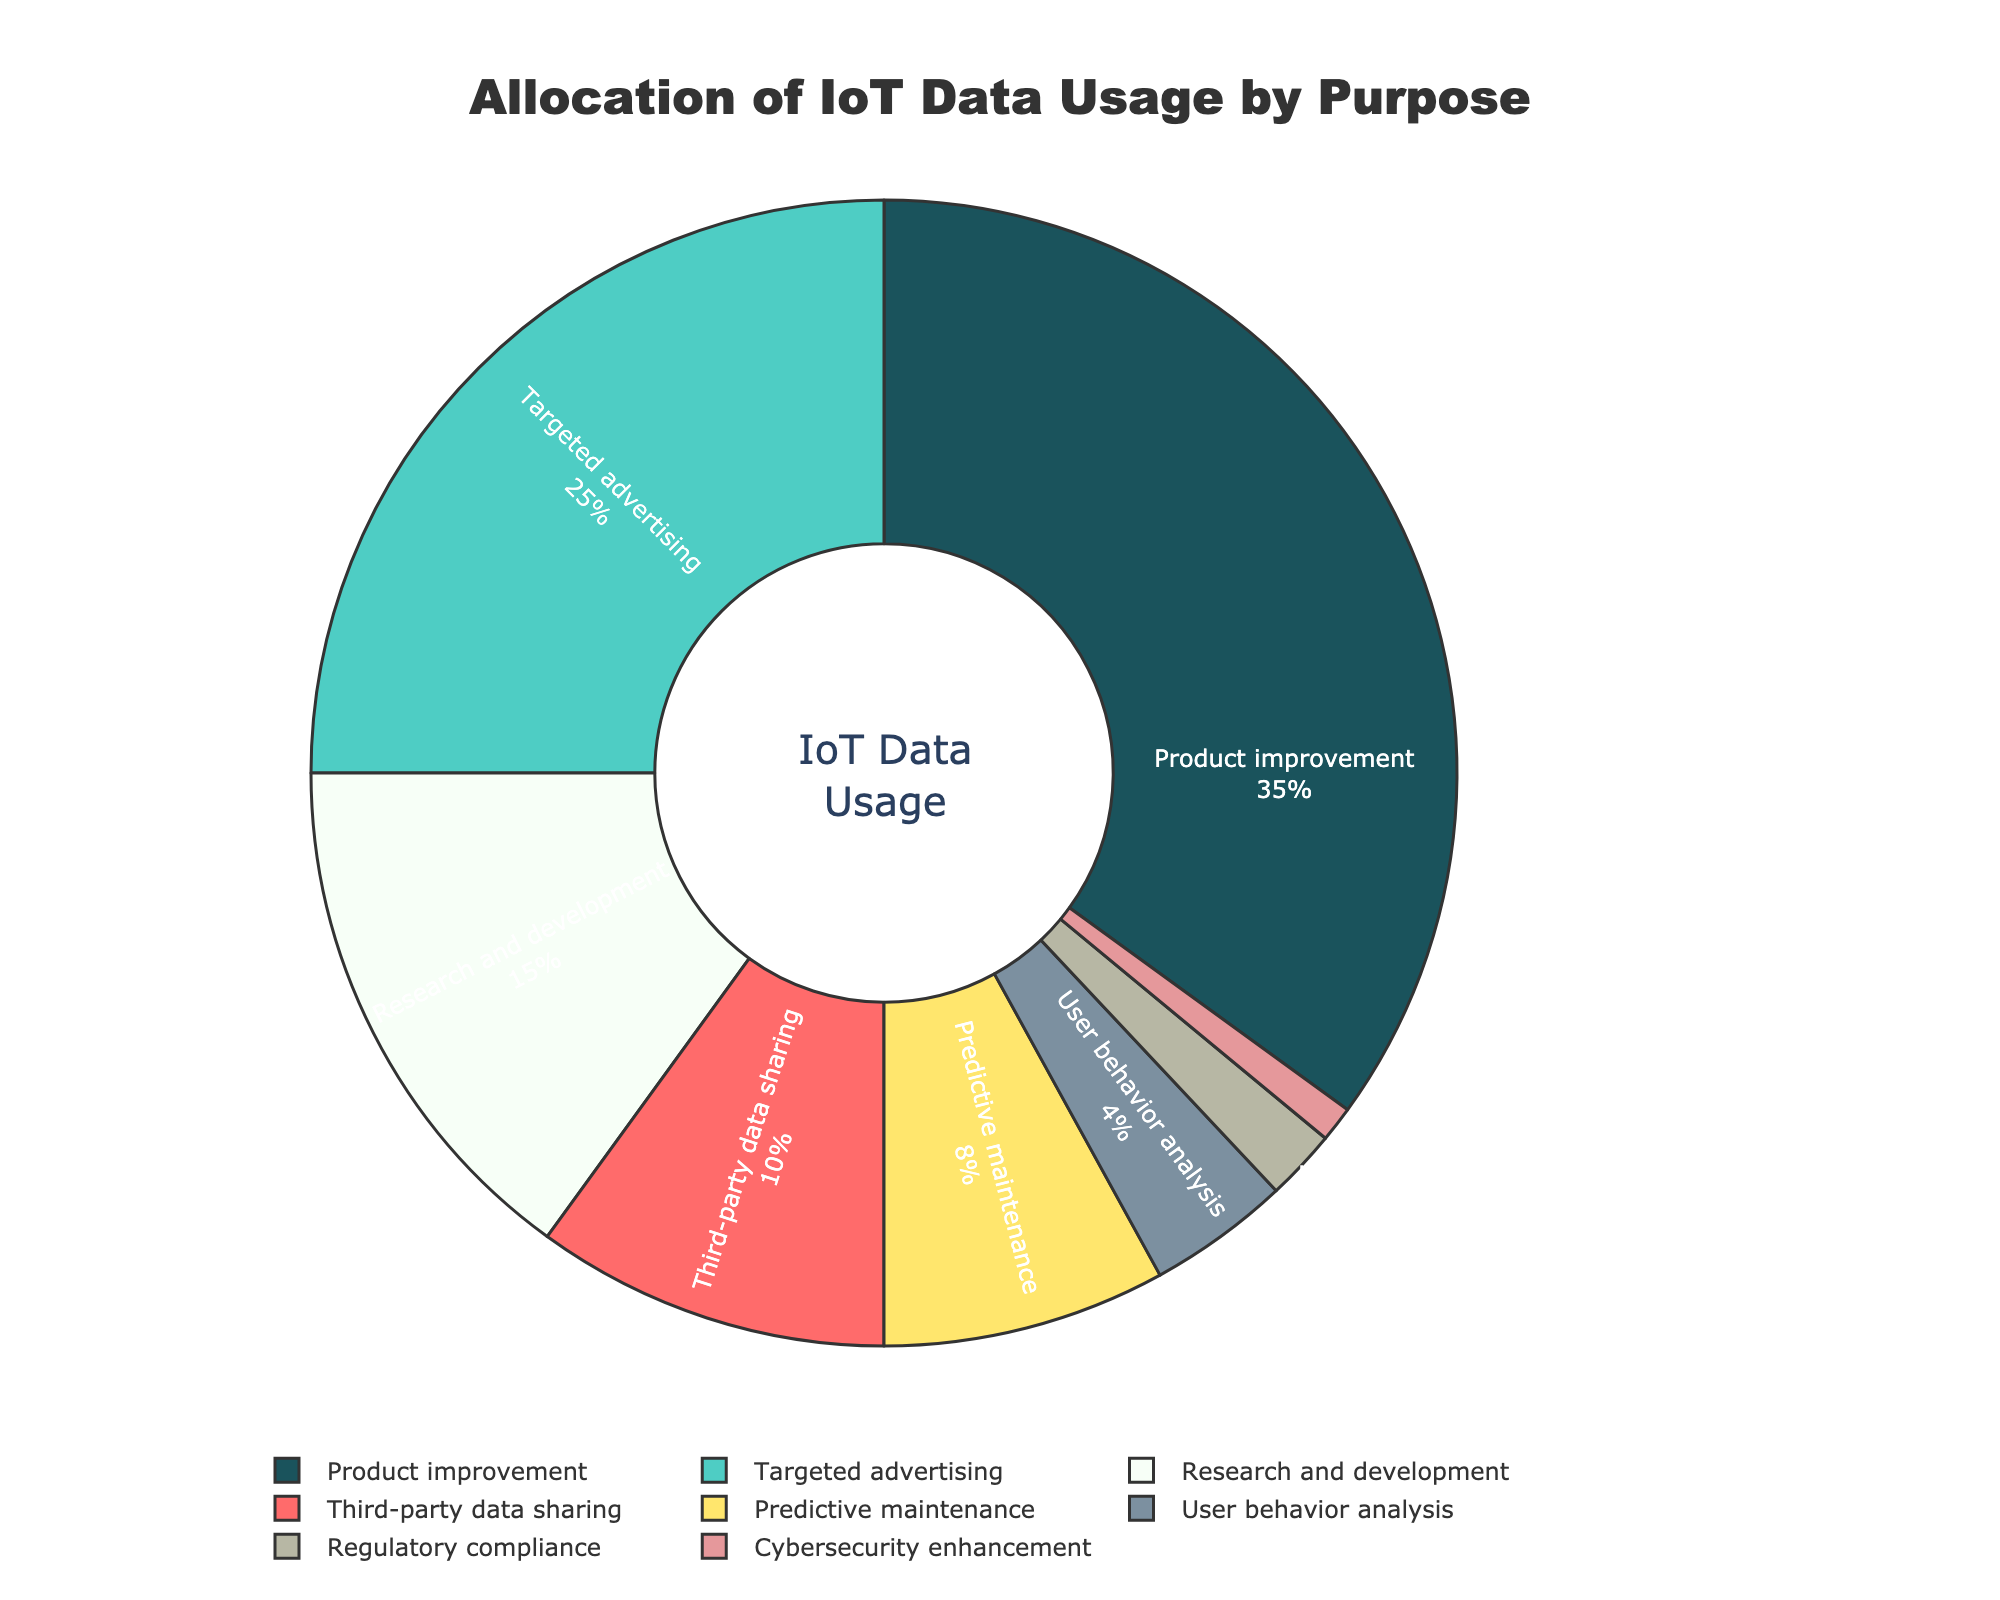What percentage of IoT data is used for product improvement? Look at the segment labeled "Product improvement" in the pie chart. The percentage value displayed next to the label is 35%.
Answer: 35% Which purpose uses more IoT data, targeted advertising or research and development? Compare the percentage values of the segments labeled "Targeted advertising" (25%) and "Research and development" (15%). The percentage for targeted advertising is higher than for research and development.
Answer: Targeted advertising How much more IoT data is allocated to product improvement compared to third-party data sharing? Subtract the percentage value of "Third-party data sharing" (10%) from "Product improvement" (35%). 35% - 10% = 25%.
Answer: 25% What is the combined percentage of IoT data used for predictive maintenance and user behavior analysis? Add the percentage values of "Predictive maintenance" (8%) and "User behavior analysis" (4%). 8% + 4% = 12%.
Answer: 12% What is the least common purpose for IoT data usage? Identify the segment with the smallest percentage value. The segment labeled "Cybersecurity enhancement" has the lowest percentage value (1%).
Answer: Cybersecurity enhancement What is the total percentage of IoT data allocated to research and development, regulatory compliance, and cybersecurity enhancement? Add the percentage values of "Research and development" (15%), "Regulatory compliance" (2%), and "Cybersecurity enhancement" (1%). 15% + 2% + 1% = 18%.
Answer: 18% Is the percentage of IoT data used for third-party data sharing greater or less than the combined percentage for regulatory compliance and cybersecurity enhancement? Compare 10% (third-party data sharing) to the sum of regulatory compliance (2%) and cybersecurity enhancement (1%), which equals 3%. 10% is greater than 3%.
Answer: Greater What percentage of IoT data is allocated to product improvement and targeted advertising combined? Add the percentage values of "Product improvement" (35%) and "Targeted advertising" (25%). 35% + 25% = 60%.
Answer: 60% What is the difference in percentage between user behavior analysis and predictive maintenance? Subtract the percentage value of "User behavior analysis" (4%) from "Predictive maintenance" (8%). 8% - 4% = 4%.
Answer: 4% 